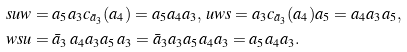Convert formula to latex. <formula><loc_0><loc_0><loc_500><loc_500>& s u w = a _ { 5 } a _ { 3 } c _ { \bar { a } _ { 3 } } ( a _ { 4 } ) = a _ { 5 } a _ { 4 } a _ { 3 } , \, u w s = a _ { 3 } c _ { \bar { a } _ { 3 } } ( a _ { 4 } ) a _ { 5 } = a _ { 4 } a _ { 3 } a _ { 5 } , \\ & w s u = \bar { a } _ { 3 } \, a _ { 4 } a _ { 3 } a _ { 5 } \, a _ { 3 } = \bar { a } _ { 3 } a _ { 3 } a _ { 5 } a _ { 4 } a _ { 3 } = a _ { 5 } a _ { 4 } a _ { 3 } .</formula> 